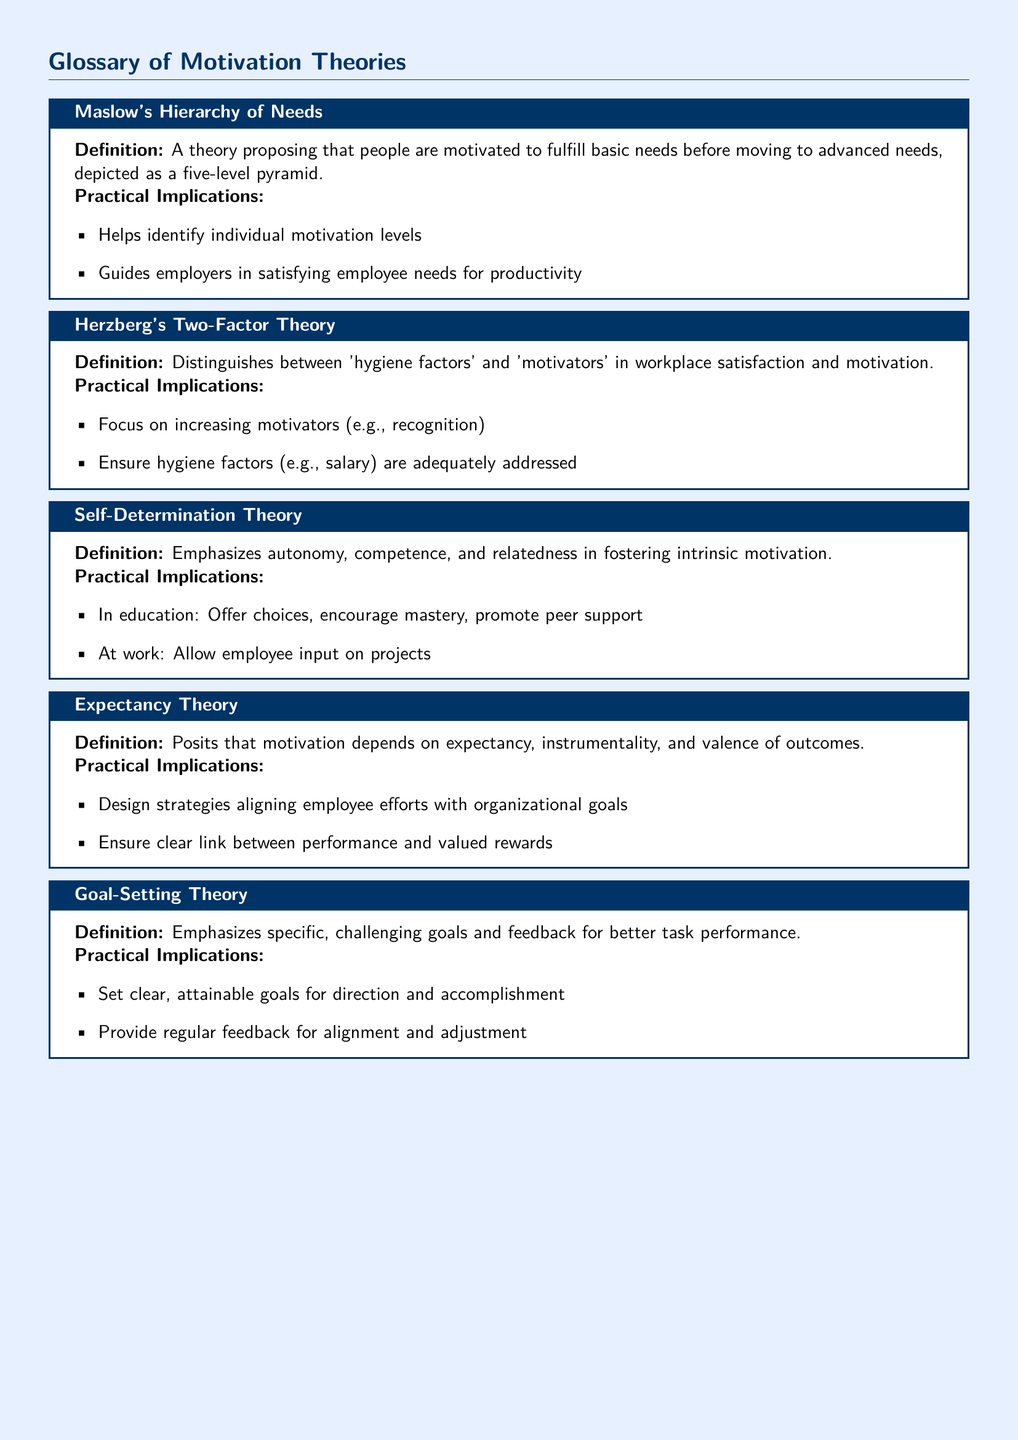What is the first theory mentioned in the glossary? The first theory listed is the initial term described in the document.
Answer: Maslow's Hierarchy of Needs What are the three components emphasized in Self-Determination Theory? The components are specifically defined in the document under this theory's practical implications.
Answer: Autonomy, competence, relatedness What type of theory is Herzberg's Two-Factor Theory classified as? This information is categorized under the definition section of the corresponding theory.
Answer: Motivation theory What is the focus of Goal-Setting Theory? The focus is highlighted in the definition of this theory within the document.
Answer: Specific, challenging goals and feedback How many levels are depicted in Maslow's hierarchy? The number of levels is explicitly stated in the definition of this theory.
Answer: Five What does Expectancy Theory evaluate? This theory assesses a specific relationship outlined in the document’s definition.
Answer: Expectancy, instrumentality, and valence of outcomes What should be ensured regarding hygiene factors according to Herzberg's Two-Factor Theory? This is stated in the practical implications section of Herzberg's theory.
Answer: Adequately addressed What type of feedback is important in Goal-Setting Theory? The type of feedback required is mentioned in the practical implications section.
Answer: Regular feedback 